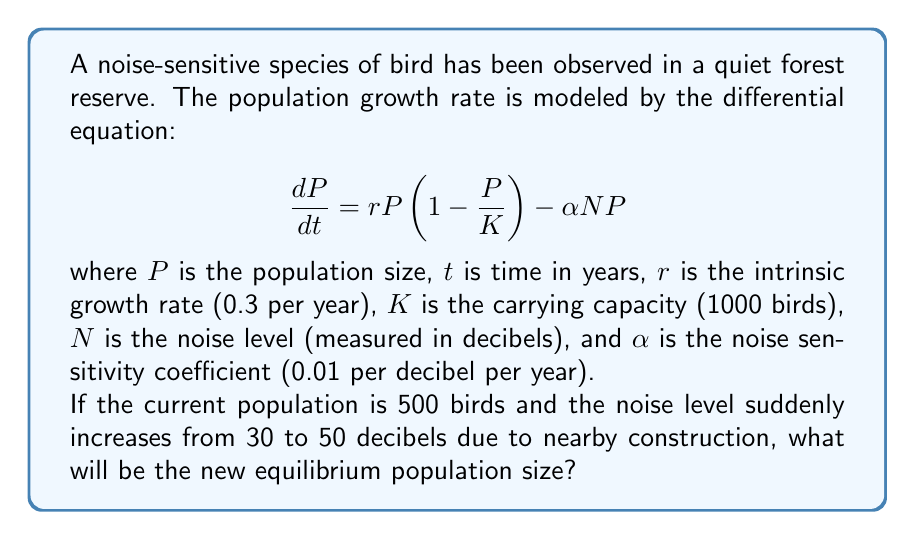Can you answer this question? To find the equilibrium population size, we need to set $\frac{dP}{dt} = 0$ and solve for $P$. This gives us:

$$0 = rP\left(1 - \frac{P}{K}\right) - \alpha N P$$

Factoring out $P$:

$$0 = P\left(r\left(1 - \frac{P}{K}\right) - \alpha N\right)$$

The non-trivial solution (P ≠ 0) is:

$$r\left(1 - \frac{P}{K}\right) - \alpha N = 0$$

Solving for $P$:

$$1 - \frac{P}{K} = \frac{\alpha N}{r}$$
$$\frac{P}{K} = 1 - \frac{\alpha N}{r}$$
$$P = K\left(1 - \frac{\alpha N}{r}\right)$$

Now, let's substitute the given values:

$K = 1000$
$\alpha = 0.01$
$r = 0.3$
$N = 50$ (new noise level)

$$P = 1000\left(1 - \frac{0.01 \cdot 50}{0.3}\right)$$
$$P = 1000\left(1 - \frac{0.5}{0.3}\right)$$
$$P = 1000(1 - 1.67)$$
$$P = 1000(-0.67)$$
$$P = -670$$

However, a negative population size is not biologically meaningful. This indicates that the noise level is too high for the population to sustain itself, and the equilibrium population size will be 0.
Answer: The new equilibrium population size will be 0 birds, as the increased noise level makes the environment unsuitable for the species to maintain a positive population. 